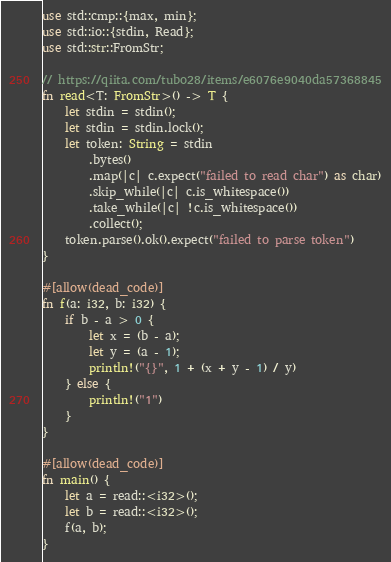<code> <loc_0><loc_0><loc_500><loc_500><_Rust_>use std::cmp::{max, min};
use std::io::{stdin, Read};
use std::str::FromStr;

// https://qiita.com/tubo28/items/e6076e9040da57368845
fn read<T: FromStr>() -> T {
    let stdin = stdin();
    let stdin = stdin.lock();
    let token: String = stdin
        .bytes()
        .map(|c| c.expect("failed to read char") as char)
        .skip_while(|c| c.is_whitespace())
        .take_while(|c| !c.is_whitespace())
        .collect();
    token.parse().ok().expect("failed to parse token")
}

#[allow(dead_code)]
fn f(a: i32, b: i32) {
    if b - a > 0 {
        let x = (b - a);
        let y = (a - 1);
        println!("{}", 1 + (x + y - 1) / y)
    } else {
        println!("1")
    }
}

#[allow(dead_code)]
fn main() {
    let a = read::<i32>();
    let b = read::<i32>();
    f(a, b);
}
</code> 